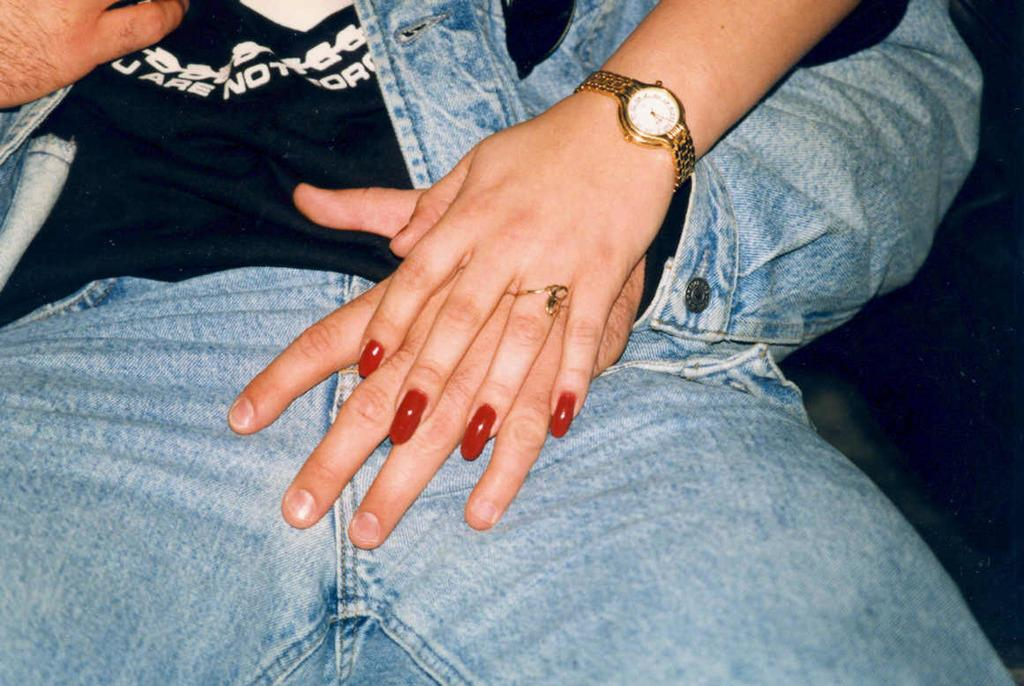What is the gender of the person in the image? The person appears to be a woman. What is the woman wearing in the image? The woman is wearing clothes. Can you describe the woman's hand in the image? The woman's hand is visible in the image, and she is wearing a finger ring. What type of accessory is the woman wearing on her wrist? The woman is wearing a wrist watch. What can be seen on the woman's nails in the image? The woman has nail polish on her nails. What quarter is the woman's dad playing in the image? There is no reference to a quarter or the woman's dad in the image, so it's not possible to answer that question. 